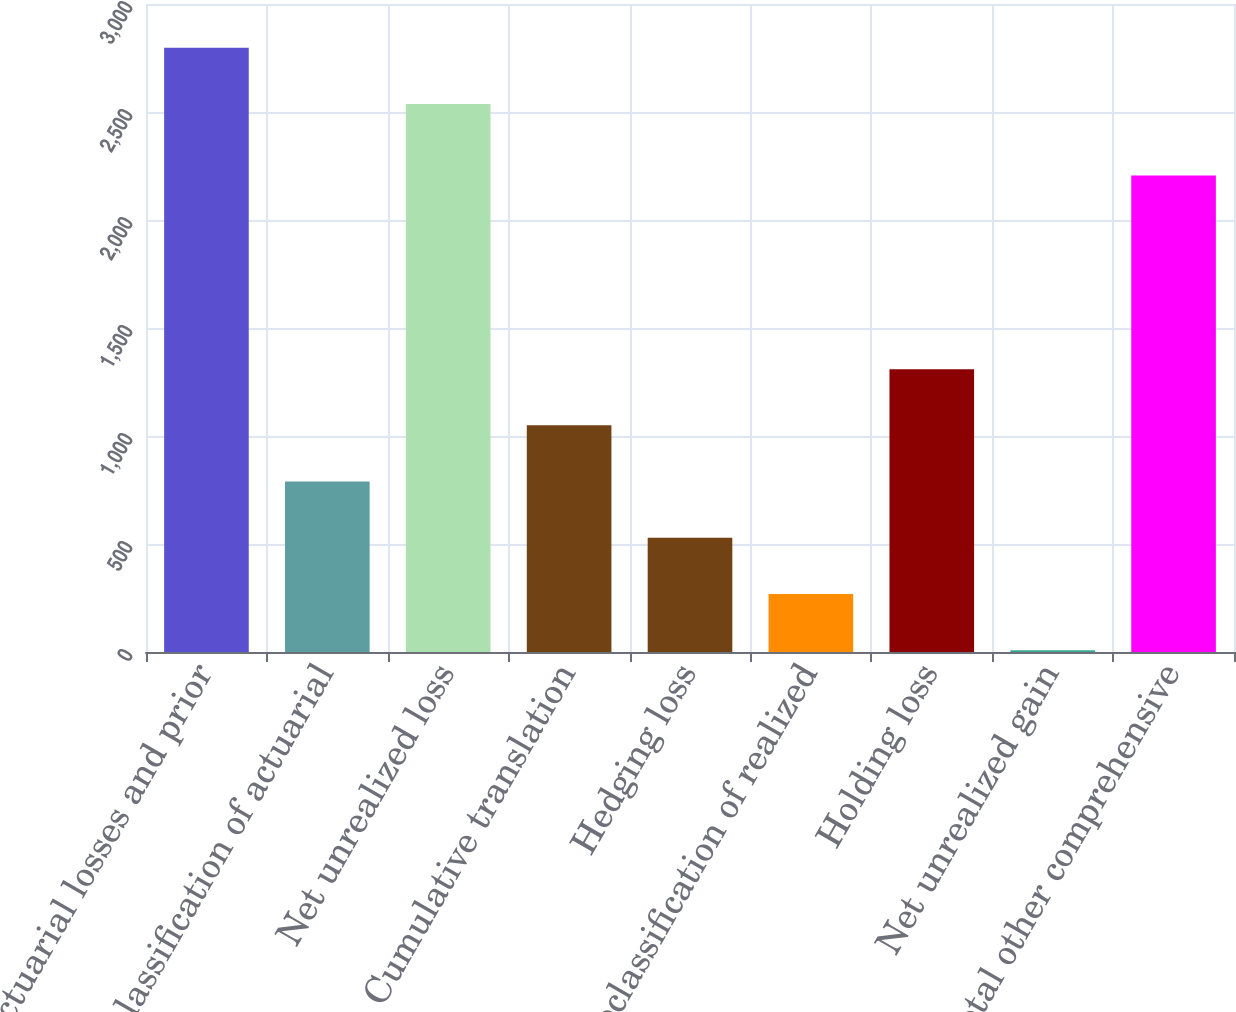Convert chart to OTSL. <chart><loc_0><loc_0><loc_500><loc_500><bar_chart><fcel>Net actuarial losses and prior<fcel>Reclassification of actuarial<fcel>Net unrealized loss<fcel>Cumulative translation<fcel>Hedging loss<fcel>Reclassification of realized<fcel>Holding loss<fcel>Net unrealized gain<fcel>Total other comprehensive<nl><fcel>2797.3<fcel>788.9<fcel>2537<fcel>1049.2<fcel>528.6<fcel>268.3<fcel>1309.5<fcel>8<fcel>2206<nl></chart> 